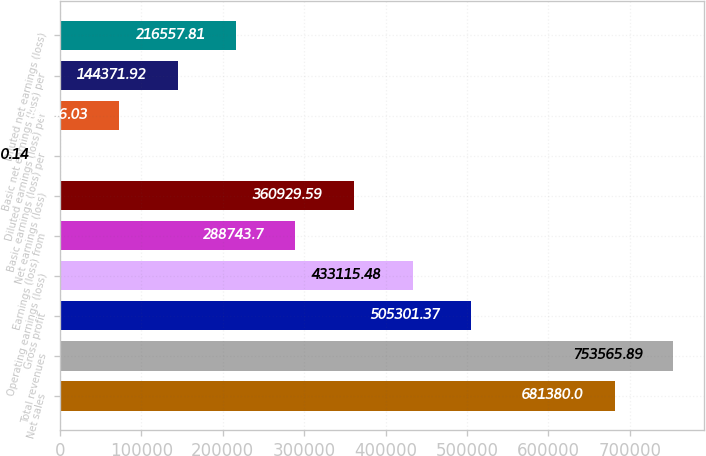Convert chart. <chart><loc_0><loc_0><loc_500><loc_500><bar_chart><fcel>Net sales<fcel>Total revenues<fcel>Gross profit<fcel>Operating earnings (loss)<fcel>Earnings (loss) from<fcel>Net earnings (loss)<fcel>Basic earnings (loss) per<fcel>Diluted earnings (loss) per<fcel>Basic net earnings (loss) per<fcel>Diluted net earnings (loss)<nl><fcel>681380<fcel>753566<fcel>505301<fcel>433115<fcel>288744<fcel>360930<fcel>0.14<fcel>72186<fcel>144372<fcel>216558<nl></chart> 